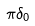Convert formula to latex. <formula><loc_0><loc_0><loc_500><loc_500>\pi \delta _ { 0 }</formula> 